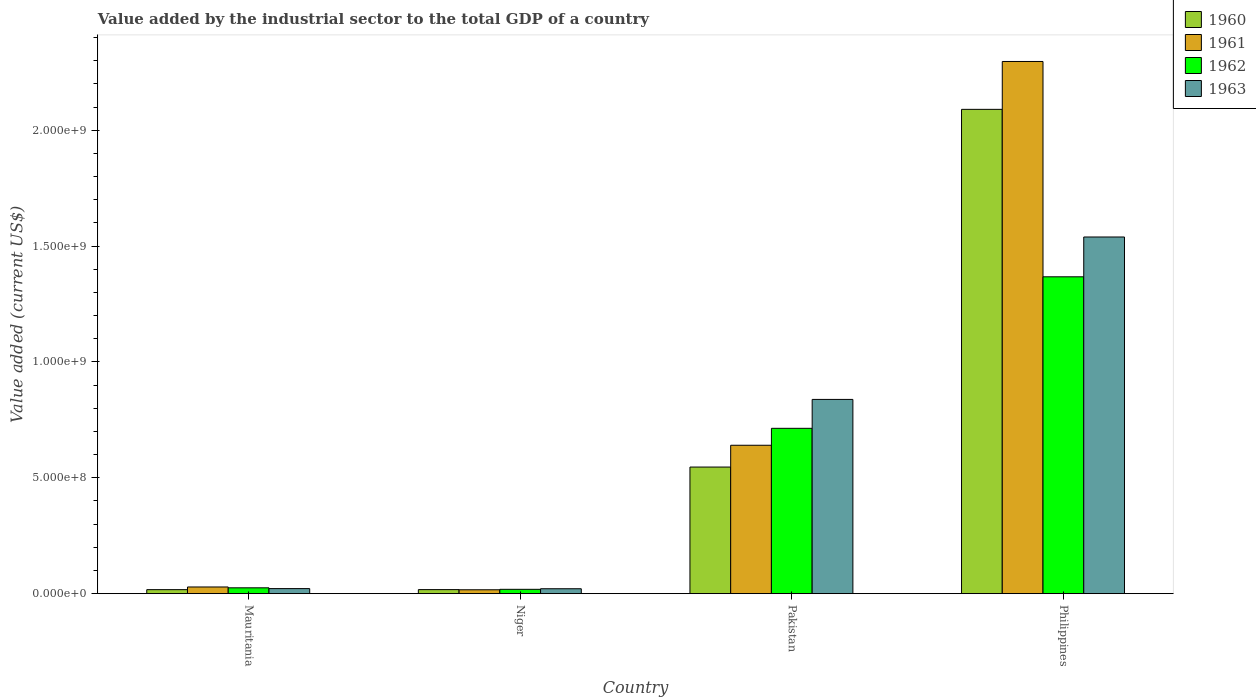Are the number of bars per tick equal to the number of legend labels?
Your answer should be very brief. Yes. Are the number of bars on each tick of the X-axis equal?
Keep it short and to the point. Yes. What is the label of the 1st group of bars from the left?
Provide a succinct answer. Mauritania. What is the value added by the industrial sector to the total GDP in 1963 in Pakistan?
Ensure brevity in your answer.  8.38e+08. Across all countries, what is the maximum value added by the industrial sector to the total GDP in 1963?
Keep it short and to the point. 1.54e+09. Across all countries, what is the minimum value added by the industrial sector to the total GDP in 1961?
Offer a terse response. 1.67e+07. In which country was the value added by the industrial sector to the total GDP in 1961 minimum?
Provide a succinct answer. Niger. What is the total value added by the industrial sector to the total GDP in 1962 in the graph?
Keep it short and to the point. 2.12e+09. What is the difference between the value added by the industrial sector to the total GDP in 1962 in Mauritania and that in Niger?
Provide a short and direct response. 6.51e+06. What is the difference between the value added by the industrial sector to the total GDP in 1960 in Mauritania and the value added by the industrial sector to the total GDP in 1961 in Pakistan?
Make the answer very short. -6.23e+08. What is the average value added by the industrial sector to the total GDP in 1961 per country?
Offer a terse response. 7.46e+08. What is the difference between the value added by the industrial sector to the total GDP of/in 1960 and value added by the industrial sector to the total GDP of/in 1962 in Philippines?
Give a very brief answer. 7.23e+08. What is the ratio of the value added by the industrial sector to the total GDP in 1960 in Mauritania to that in Philippines?
Keep it short and to the point. 0.01. Is the value added by the industrial sector to the total GDP in 1963 in Mauritania less than that in Pakistan?
Your answer should be very brief. Yes. Is the difference between the value added by the industrial sector to the total GDP in 1960 in Pakistan and Philippines greater than the difference between the value added by the industrial sector to the total GDP in 1962 in Pakistan and Philippines?
Ensure brevity in your answer.  No. What is the difference between the highest and the second highest value added by the industrial sector to the total GDP in 1963?
Provide a short and direct response. -7.01e+08. What is the difference between the highest and the lowest value added by the industrial sector to the total GDP in 1960?
Offer a terse response. 2.07e+09. What does the 1st bar from the left in Pakistan represents?
Give a very brief answer. 1960. What does the 2nd bar from the right in Philippines represents?
Offer a terse response. 1962. Is it the case that in every country, the sum of the value added by the industrial sector to the total GDP in 1961 and value added by the industrial sector to the total GDP in 1962 is greater than the value added by the industrial sector to the total GDP in 1963?
Provide a short and direct response. Yes. Are the values on the major ticks of Y-axis written in scientific E-notation?
Provide a short and direct response. Yes. Does the graph contain any zero values?
Ensure brevity in your answer.  No. How many legend labels are there?
Your answer should be very brief. 4. What is the title of the graph?
Provide a short and direct response. Value added by the industrial sector to the total GDP of a country. What is the label or title of the X-axis?
Keep it short and to the point. Country. What is the label or title of the Y-axis?
Your answer should be very brief. Value added (current US$). What is the Value added (current US$) of 1960 in Mauritania?
Your answer should be compact. 1.73e+07. What is the Value added (current US$) in 1961 in Mauritania?
Offer a very short reply. 2.88e+07. What is the Value added (current US$) of 1962 in Mauritania?
Provide a succinct answer. 2.52e+07. What is the Value added (current US$) of 1963 in Mauritania?
Give a very brief answer. 2.18e+07. What is the Value added (current US$) of 1960 in Niger?
Keep it short and to the point. 1.75e+07. What is the Value added (current US$) in 1961 in Niger?
Your answer should be compact. 1.67e+07. What is the Value added (current US$) in 1962 in Niger?
Ensure brevity in your answer.  1.87e+07. What is the Value added (current US$) of 1963 in Niger?
Ensure brevity in your answer.  2.12e+07. What is the Value added (current US$) in 1960 in Pakistan?
Your response must be concise. 5.46e+08. What is the Value added (current US$) of 1961 in Pakistan?
Provide a short and direct response. 6.40e+08. What is the Value added (current US$) of 1962 in Pakistan?
Keep it short and to the point. 7.14e+08. What is the Value added (current US$) in 1963 in Pakistan?
Keep it short and to the point. 8.38e+08. What is the Value added (current US$) of 1960 in Philippines?
Make the answer very short. 2.09e+09. What is the Value added (current US$) in 1961 in Philippines?
Provide a short and direct response. 2.30e+09. What is the Value added (current US$) of 1962 in Philippines?
Offer a terse response. 1.37e+09. What is the Value added (current US$) in 1963 in Philippines?
Offer a very short reply. 1.54e+09. Across all countries, what is the maximum Value added (current US$) in 1960?
Ensure brevity in your answer.  2.09e+09. Across all countries, what is the maximum Value added (current US$) of 1961?
Your answer should be very brief. 2.30e+09. Across all countries, what is the maximum Value added (current US$) of 1962?
Your answer should be very brief. 1.37e+09. Across all countries, what is the maximum Value added (current US$) in 1963?
Make the answer very short. 1.54e+09. Across all countries, what is the minimum Value added (current US$) of 1960?
Your answer should be compact. 1.73e+07. Across all countries, what is the minimum Value added (current US$) of 1961?
Your answer should be very brief. 1.67e+07. Across all countries, what is the minimum Value added (current US$) in 1962?
Offer a terse response. 1.87e+07. Across all countries, what is the minimum Value added (current US$) of 1963?
Offer a very short reply. 2.12e+07. What is the total Value added (current US$) of 1960 in the graph?
Your answer should be compact. 2.67e+09. What is the total Value added (current US$) in 1961 in the graph?
Offer a very short reply. 2.98e+09. What is the total Value added (current US$) of 1962 in the graph?
Your answer should be compact. 2.12e+09. What is the total Value added (current US$) of 1963 in the graph?
Provide a short and direct response. 2.42e+09. What is the difference between the Value added (current US$) of 1960 in Mauritania and that in Niger?
Ensure brevity in your answer.  -1.73e+05. What is the difference between the Value added (current US$) of 1961 in Mauritania and that in Niger?
Your answer should be compact. 1.21e+07. What is the difference between the Value added (current US$) of 1962 in Mauritania and that in Niger?
Your answer should be very brief. 6.51e+06. What is the difference between the Value added (current US$) of 1963 in Mauritania and that in Niger?
Keep it short and to the point. 6.57e+05. What is the difference between the Value added (current US$) of 1960 in Mauritania and that in Pakistan?
Your answer should be very brief. -5.29e+08. What is the difference between the Value added (current US$) in 1961 in Mauritania and that in Pakistan?
Offer a very short reply. -6.12e+08. What is the difference between the Value added (current US$) in 1962 in Mauritania and that in Pakistan?
Your answer should be compact. -6.88e+08. What is the difference between the Value added (current US$) in 1963 in Mauritania and that in Pakistan?
Give a very brief answer. -8.16e+08. What is the difference between the Value added (current US$) of 1960 in Mauritania and that in Philippines?
Your response must be concise. -2.07e+09. What is the difference between the Value added (current US$) in 1961 in Mauritania and that in Philippines?
Your answer should be compact. -2.27e+09. What is the difference between the Value added (current US$) in 1962 in Mauritania and that in Philippines?
Provide a succinct answer. -1.34e+09. What is the difference between the Value added (current US$) of 1963 in Mauritania and that in Philippines?
Offer a terse response. -1.52e+09. What is the difference between the Value added (current US$) in 1960 in Niger and that in Pakistan?
Make the answer very short. -5.29e+08. What is the difference between the Value added (current US$) in 1961 in Niger and that in Pakistan?
Your response must be concise. -6.24e+08. What is the difference between the Value added (current US$) of 1962 in Niger and that in Pakistan?
Keep it short and to the point. -6.95e+08. What is the difference between the Value added (current US$) of 1963 in Niger and that in Pakistan?
Keep it short and to the point. -8.17e+08. What is the difference between the Value added (current US$) in 1960 in Niger and that in Philippines?
Your answer should be very brief. -2.07e+09. What is the difference between the Value added (current US$) in 1961 in Niger and that in Philippines?
Your response must be concise. -2.28e+09. What is the difference between the Value added (current US$) of 1962 in Niger and that in Philippines?
Give a very brief answer. -1.35e+09. What is the difference between the Value added (current US$) in 1963 in Niger and that in Philippines?
Offer a very short reply. -1.52e+09. What is the difference between the Value added (current US$) in 1960 in Pakistan and that in Philippines?
Offer a very short reply. -1.54e+09. What is the difference between the Value added (current US$) of 1961 in Pakistan and that in Philippines?
Your answer should be very brief. -1.66e+09. What is the difference between the Value added (current US$) of 1962 in Pakistan and that in Philippines?
Make the answer very short. -6.54e+08. What is the difference between the Value added (current US$) of 1963 in Pakistan and that in Philippines?
Your response must be concise. -7.01e+08. What is the difference between the Value added (current US$) of 1960 in Mauritania and the Value added (current US$) of 1961 in Niger?
Your answer should be compact. 5.53e+05. What is the difference between the Value added (current US$) of 1960 in Mauritania and the Value added (current US$) of 1962 in Niger?
Provide a short and direct response. -1.42e+06. What is the difference between the Value added (current US$) of 1960 in Mauritania and the Value added (current US$) of 1963 in Niger?
Provide a short and direct response. -3.89e+06. What is the difference between the Value added (current US$) in 1961 in Mauritania and the Value added (current US$) in 1962 in Niger?
Keep it short and to the point. 1.01e+07. What is the difference between the Value added (current US$) in 1961 in Mauritania and the Value added (current US$) in 1963 in Niger?
Provide a short and direct response. 7.64e+06. What is the difference between the Value added (current US$) of 1962 in Mauritania and the Value added (current US$) of 1963 in Niger?
Provide a short and direct response. 4.04e+06. What is the difference between the Value added (current US$) in 1960 in Mauritania and the Value added (current US$) in 1961 in Pakistan?
Offer a very short reply. -6.23e+08. What is the difference between the Value added (current US$) of 1960 in Mauritania and the Value added (current US$) of 1962 in Pakistan?
Your response must be concise. -6.96e+08. What is the difference between the Value added (current US$) in 1960 in Mauritania and the Value added (current US$) in 1963 in Pakistan?
Keep it short and to the point. -8.21e+08. What is the difference between the Value added (current US$) in 1961 in Mauritania and the Value added (current US$) in 1962 in Pakistan?
Make the answer very short. -6.85e+08. What is the difference between the Value added (current US$) of 1961 in Mauritania and the Value added (current US$) of 1963 in Pakistan?
Give a very brief answer. -8.09e+08. What is the difference between the Value added (current US$) of 1962 in Mauritania and the Value added (current US$) of 1963 in Pakistan?
Offer a terse response. -8.13e+08. What is the difference between the Value added (current US$) in 1960 in Mauritania and the Value added (current US$) in 1961 in Philippines?
Ensure brevity in your answer.  -2.28e+09. What is the difference between the Value added (current US$) of 1960 in Mauritania and the Value added (current US$) of 1962 in Philippines?
Offer a very short reply. -1.35e+09. What is the difference between the Value added (current US$) of 1960 in Mauritania and the Value added (current US$) of 1963 in Philippines?
Provide a succinct answer. -1.52e+09. What is the difference between the Value added (current US$) in 1961 in Mauritania and the Value added (current US$) in 1962 in Philippines?
Provide a short and direct response. -1.34e+09. What is the difference between the Value added (current US$) of 1961 in Mauritania and the Value added (current US$) of 1963 in Philippines?
Give a very brief answer. -1.51e+09. What is the difference between the Value added (current US$) in 1962 in Mauritania and the Value added (current US$) in 1963 in Philippines?
Offer a very short reply. -1.51e+09. What is the difference between the Value added (current US$) in 1960 in Niger and the Value added (current US$) in 1961 in Pakistan?
Keep it short and to the point. -6.23e+08. What is the difference between the Value added (current US$) of 1960 in Niger and the Value added (current US$) of 1962 in Pakistan?
Make the answer very short. -6.96e+08. What is the difference between the Value added (current US$) of 1960 in Niger and the Value added (current US$) of 1963 in Pakistan?
Provide a succinct answer. -8.21e+08. What is the difference between the Value added (current US$) in 1961 in Niger and the Value added (current US$) in 1962 in Pakistan?
Keep it short and to the point. -6.97e+08. What is the difference between the Value added (current US$) of 1961 in Niger and the Value added (current US$) of 1963 in Pakistan?
Keep it short and to the point. -8.22e+08. What is the difference between the Value added (current US$) of 1962 in Niger and the Value added (current US$) of 1963 in Pakistan?
Give a very brief answer. -8.20e+08. What is the difference between the Value added (current US$) in 1960 in Niger and the Value added (current US$) in 1961 in Philippines?
Your response must be concise. -2.28e+09. What is the difference between the Value added (current US$) of 1960 in Niger and the Value added (current US$) of 1962 in Philippines?
Ensure brevity in your answer.  -1.35e+09. What is the difference between the Value added (current US$) of 1960 in Niger and the Value added (current US$) of 1963 in Philippines?
Make the answer very short. -1.52e+09. What is the difference between the Value added (current US$) in 1961 in Niger and the Value added (current US$) in 1962 in Philippines?
Make the answer very short. -1.35e+09. What is the difference between the Value added (current US$) in 1961 in Niger and the Value added (current US$) in 1963 in Philippines?
Provide a short and direct response. -1.52e+09. What is the difference between the Value added (current US$) in 1962 in Niger and the Value added (current US$) in 1963 in Philippines?
Ensure brevity in your answer.  -1.52e+09. What is the difference between the Value added (current US$) of 1960 in Pakistan and the Value added (current US$) of 1961 in Philippines?
Make the answer very short. -1.75e+09. What is the difference between the Value added (current US$) in 1960 in Pakistan and the Value added (current US$) in 1962 in Philippines?
Offer a terse response. -8.21e+08. What is the difference between the Value added (current US$) of 1960 in Pakistan and the Value added (current US$) of 1963 in Philippines?
Offer a terse response. -9.93e+08. What is the difference between the Value added (current US$) in 1961 in Pakistan and the Value added (current US$) in 1962 in Philippines?
Your answer should be very brief. -7.27e+08. What is the difference between the Value added (current US$) of 1961 in Pakistan and the Value added (current US$) of 1963 in Philippines?
Your answer should be compact. -8.99e+08. What is the difference between the Value added (current US$) of 1962 in Pakistan and the Value added (current US$) of 1963 in Philippines?
Provide a succinct answer. -8.26e+08. What is the average Value added (current US$) of 1960 per country?
Offer a very short reply. 6.68e+08. What is the average Value added (current US$) of 1961 per country?
Provide a short and direct response. 7.46e+08. What is the average Value added (current US$) in 1962 per country?
Your answer should be very brief. 5.31e+08. What is the average Value added (current US$) of 1963 per country?
Provide a succinct answer. 6.05e+08. What is the difference between the Value added (current US$) of 1960 and Value added (current US$) of 1961 in Mauritania?
Offer a very short reply. -1.15e+07. What is the difference between the Value added (current US$) in 1960 and Value added (current US$) in 1962 in Mauritania?
Keep it short and to the point. -7.93e+06. What is the difference between the Value added (current US$) of 1960 and Value added (current US$) of 1963 in Mauritania?
Your answer should be very brief. -4.55e+06. What is the difference between the Value added (current US$) of 1961 and Value added (current US$) of 1962 in Mauritania?
Provide a short and direct response. 3.60e+06. What is the difference between the Value added (current US$) of 1961 and Value added (current US$) of 1963 in Mauritania?
Your response must be concise. 6.98e+06. What is the difference between the Value added (current US$) in 1962 and Value added (current US$) in 1963 in Mauritania?
Make the answer very short. 3.38e+06. What is the difference between the Value added (current US$) of 1960 and Value added (current US$) of 1961 in Niger?
Your answer should be compact. 7.26e+05. What is the difference between the Value added (current US$) in 1960 and Value added (current US$) in 1962 in Niger?
Ensure brevity in your answer.  -1.25e+06. What is the difference between the Value added (current US$) of 1960 and Value added (current US$) of 1963 in Niger?
Ensure brevity in your answer.  -3.72e+06. What is the difference between the Value added (current US$) of 1961 and Value added (current US$) of 1962 in Niger?
Make the answer very short. -1.97e+06. What is the difference between the Value added (current US$) of 1961 and Value added (current US$) of 1963 in Niger?
Make the answer very short. -4.44e+06. What is the difference between the Value added (current US$) of 1962 and Value added (current US$) of 1963 in Niger?
Offer a terse response. -2.47e+06. What is the difference between the Value added (current US$) of 1960 and Value added (current US$) of 1961 in Pakistan?
Your answer should be very brief. -9.41e+07. What is the difference between the Value added (current US$) of 1960 and Value added (current US$) of 1962 in Pakistan?
Your answer should be very brief. -1.67e+08. What is the difference between the Value added (current US$) of 1960 and Value added (current US$) of 1963 in Pakistan?
Give a very brief answer. -2.92e+08. What is the difference between the Value added (current US$) of 1961 and Value added (current US$) of 1962 in Pakistan?
Give a very brief answer. -7.31e+07. What is the difference between the Value added (current US$) of 1961 and Value added (current US$) of 1963 in Pakistan?
Offer a terse response. -1.98e+08. What is the difference between the Value added (current US$) of 1962 and Value added (current US$) of 1963 in Pakistan?
Your answer should be very brief. -1.25e+08. What is the difference between the Value added (current US$) in 1960 and Value added (current US$) in 1961 in Philippines?
Ensure brevity in your answer.  -2.07e+08. What is the difference between the Value added (current US$) in 1960 and Value added (current US$) in 1962 in Philippines?
Make the answer very short. 7.23e+08. What is the difference between the Value added (current US$) of 1960 and Value added (current US$) of 1963 in Philippines?
Provide a short and direct response. 5.51e+08. What is the difference between the Value added (current US$) of 1961 and Value added (current US$) of 1962 in Philippines?
Offer a very short reply. 9.29e+08. What is the difference between the Value added (current US$) of 1961 and Value added (current US$) of 1963 in Philippines?
Your answer should be very brief. 7.57e+08. What is the difference between the Value added (current US$) of 1962 and Value added (current US$) of 1963 in Philippines?
Your answer should be compact. -1.72e+08. What is the ratio of the Value added (current US$) in 1960 in Mauritania to that in Niger?
Provide a short and direct response. 0.99. What is the ratio of the Value added (current US$) in 1961 in Mauritania to that in Niger?
Provide a short and direct response. 1.72. What is the ratio of the Value added (current US$) of 1962 in Mauritania to that in Niger?
Ensure brevity in your answer.  1.35. What is the ratio of the Value added (current US$) in 1963 in Mauritania to that in Niger?
Your answer should be compact. 1.03. What is the ratio of the Value added (current US$) in 1960 in Mauritania to that in Pakistan?
Offer a very short reply. 0.03. What is the ratio of the Value added (current US$) in 1961 in Mauritania to that in Pakistan?
Your answer should be very brief. 0.04. What is the ratio of the Value added (current US$) of 1962 in Mauritania to that in Pakistan?
Offer a terse response. 0.04. What is the ratio of the Value added (current US$) in 1963 in Mauritania to that in Pakistan?
Offer a very short reply. 0.03. What is the ratio of the Value added (current US$) in 1960 in Mauritania to that in Philippines?
Offer a terse response. 0.01. What is the ratio of the Value added (current US$) in 1961 in Mauritania to that in Philippines?
Provide a succinct answer. 0.01. What is the ratio of the Value added (current US$) of 1962 in Mauritania to that in Philippines?
Your answer should be very brief. 0.02. What is the ratio of the Value added (current US$) of 1963 in Mauritania to that in Philippines?
Give a very brief answer. 0.01. What is the ratio of the Value added (current US$) of 1960 in Niger to that in Pakistan?
Provide a short and direct response. 0.03. What is the ratio of the Value added (current US$) of 1961 in Niger to that in Pakistan?
Ensure brevity in your answer.  0.03. What is the ratio of the Value added (current US$) of 1962 in Niger to that in Pakistan?
Your answer should be compact. 0.03. What is the ratio of the Value added (current US$) in 1963 in Niger to that in Pakistan?
Ensure brevity in your answer.  0.03. What is the ratio of the Value added (current US$) in 1960 in Niger to that in Philippines?
Keep it short and to the point. 0.01. What is the ratio of the Value added (current US$) in 1961 in Niger to that in Philippines?
Provide a short and direct response. 0.01. What is the ratio of the Value added (current US$) of 1962 in Niger to that in Philippines?
Ensure brevity in your answer.  0.01. What is the ratio of the Value added (current US$) of 1963 in Niger to that in Philippines?
Ensure brevity in your answer.  0.01. What is the ratio of the Value added (current US$) in 1960 in Pakistan to that in Philippines?
Provide a succinct answer. 0.26. What is the ratio of the Value added (current US$) of 1961 in Pakistan to that in Philippines?
Offer a terse response. 0.28. What is the ratio of the Value added (current US$) in 1962 in Pakistan to that in Philippines?
Offer a terse response. 0.52. What is the ratio of the Value added (current US$) of 1963 in Pakistan to that in Philippines?
Provide a short and direct response. 0.54. What is the difference between the highest and the second highest Value added (current US$) of 1960?
Ensure brevity in your answer.  1.54e+09. What is the difference between the highest and the second highest Value added (current US$) of 1961?
Your answer should be very brief. 1.66e+09. What is the difference between the highest and the second highest Value added (current US$) in 1962?
Your answer should be compact. 6.54e+08. What is the difference between the highest and the second highest Value added (current US$) in 1963?
Ensure brevity in your answer.  7.01e+08. What is the difference between the highest and the lowest Value added (current US$) of 1960?
Offer a terse response. 2.07e+09. What is the difference between the highest and the lowest Value added (current US$) of 1961?
Your answer should be very brief. 2.28e+09. What is the difference between the highest and the lowest Value added (current US$) in 1962?
Offer a terse response. 1.35e+09. What is the difference between the highest and the lowest Value added (current US$) of 1963?
Your response must be concise. 1.52e+09. 